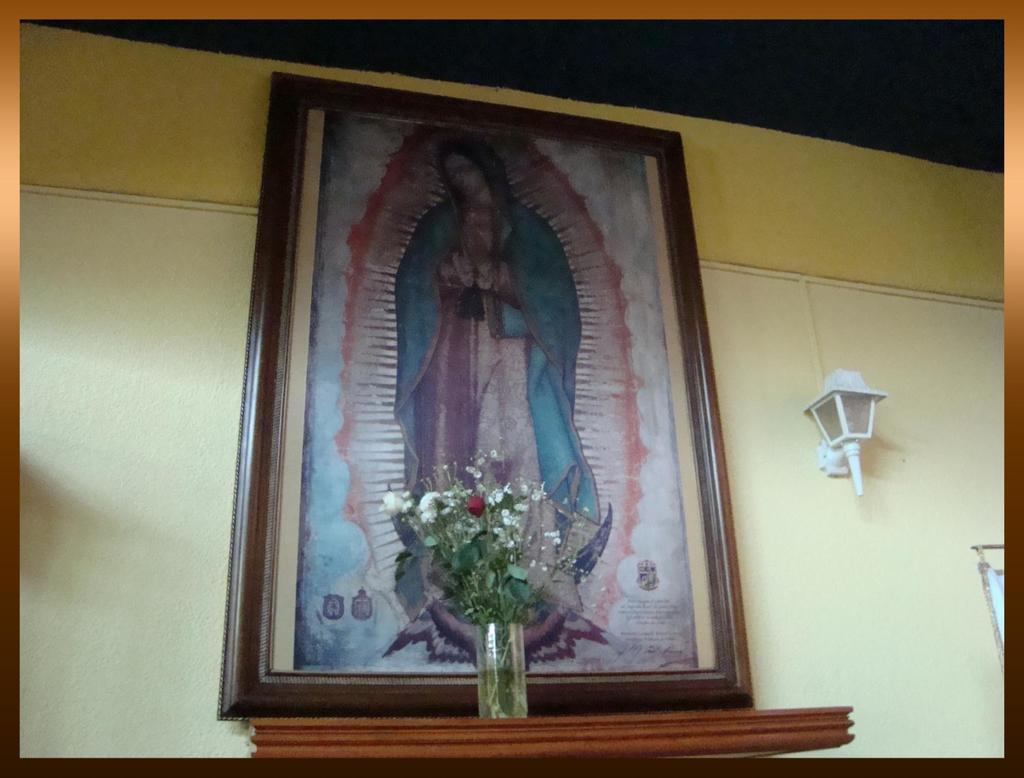What is hanging on the wall in the image? There is a photo frame on the wall. What is located next to the photo frame? There is a lamp beside the photo frame. What can be seen on the wooden platform in front of the photo frame? There are flowers on the wooden platform. How many goldfish are swimming in the wooden platform in the image? There are no goldfish present in the image; it features a photo frame, a lamp, and flowers on a wooden platform. What type of toys can be seen on the wall in the image? There are no toys visible in the image; it features a photo frame and a lamp on the wall. 